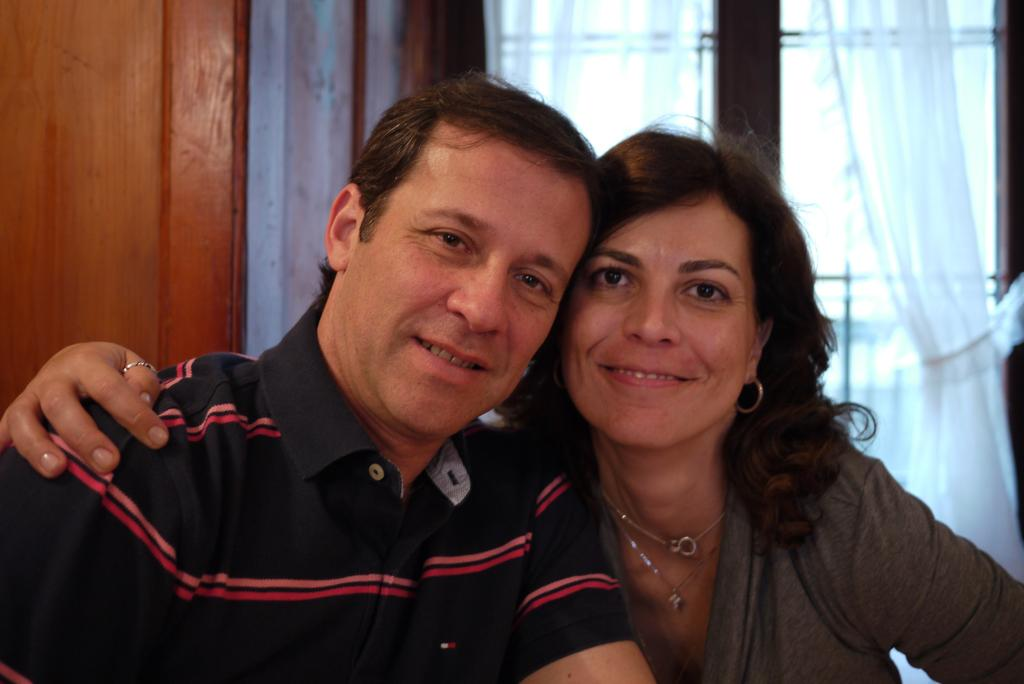Who or what can be seen in the image? There are people in the image. What is present near the window in the image? There are curtains on a window in the image. What type of pickle is being used as a prop in the image? There is no pickle present in the image. Is there a lawyer in the image? The provided facts do not mention the presence of a lawyer in the image. 